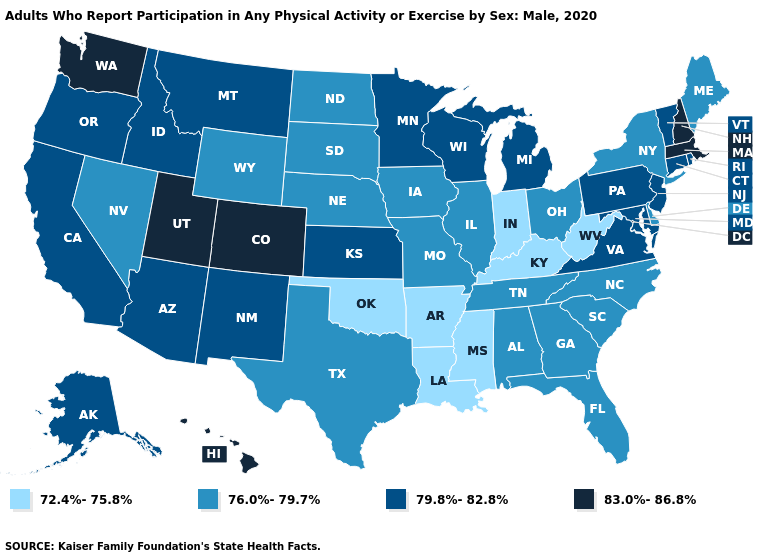Which states hav the highest value in the West?
Quick response, please. Colorado, Hawaii, Utah, Washington. What is the lowest value in the USA?
Be succinct. 72.4%-75.8%. Name the states that have a value in the range 83.0%-86.8%?
Short answer required. Colorado, Hawaii, Massachusetts, New Hampshire, Utah, Washington. Which states have the highest value in the USA?
Quick response, please. Colorado, Hawaii, Massachusetts, New Hampshire, Utah, Washington. Name the states that have a value in the range 76.0%-79.7%?
Keep it brief. Alabama, Delaware, Florida, Georgia, Illinois, Iowa, Maine, Missouri, Nebraska, Nevada, New York, North Carolina, North Dakota, Ohio, South Carolina, South Dakota, Tennessee, Texas, Wyoming. What is the value of Oregon?
Short answer required. 79.8%-82.8%. How many symbols are there in the legend?
Be succinct. 4. Among the states that border Illinois , does Iowa have the lowest value?
Answer briefly. No. What is the lowest value in states that border Pennsylvania?
Short answer required. 72.4%-75.8%. Among the states that border Texas , which have the lowest value?
Be succinct. Arkansas, Louisiana, Oklahoma. Does the first symbol in the legend represent the smallest category?
Give a very brief answer. Yes. Does Washington have the highest value in the USA?
Give a very brief answer. Yes. What is the value of Arkansas?
Concise answer only. 72.4%-75.8%. Does Minnesota have the highest value in the MidWest?
Give a very brief answer. Yes. Is the legend a continuous bar?
Concise answer only. No. 